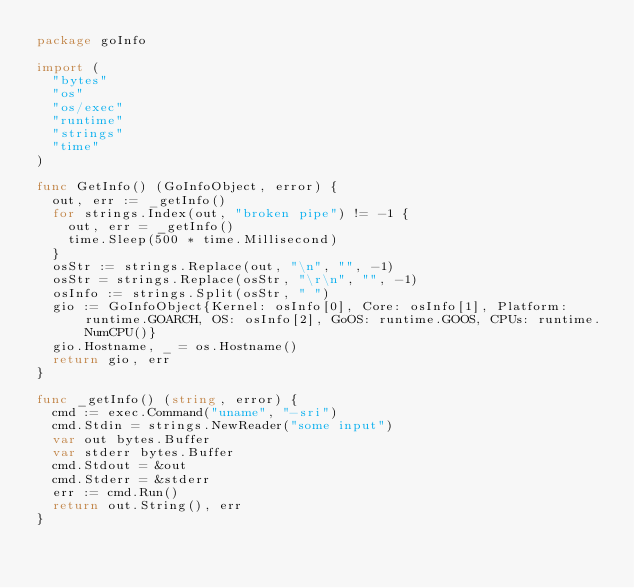Convert code to text. <code><loc_0><loc_0><loc_500><loc_500><_Go_>package goInfo

import (
	"bytes"
	"os"
	"os/exec"
	"runtime"
	"strings"
	"time"
)

func GetInfo() (GoInfoObject, error) {
	out, err := _getInfo()
	for strings.Index(out, "broken pipe") != -1 {
		out, err = _getInfo()
		time.Sleep(500 * time.Millisecond)
	}
	osStr := strings.Replace(out, "\n", "", -1)
	osStr = strings.Replace(osStr, "\r\n", "", -1)
	osInfo := strings.Split(osStr, " ")
	gio := GoInfoObject{Kernel: osInfo[0], Core: osInfo[1], Platform: runtime.GOARCH, OS: osInfo[2], GoOS: runtime.GOOS, CPUs: runtime.NumCPU()}
	gio.Hostname, _ = os.Hostname()
	return gio, err
}

func _getInfo() (string, error) {
	cmd := exec.Command("uname", "-sri")
	cmd.Stdin = strings.NewReader("some input")
	var out bytes.Buffer
	var stderr bytes.Buffer
	cmd.Stdout = &out
	cmd.Stderr = &stderr
	err := cmd.Run()
	return out.String(), err
}
</code> 